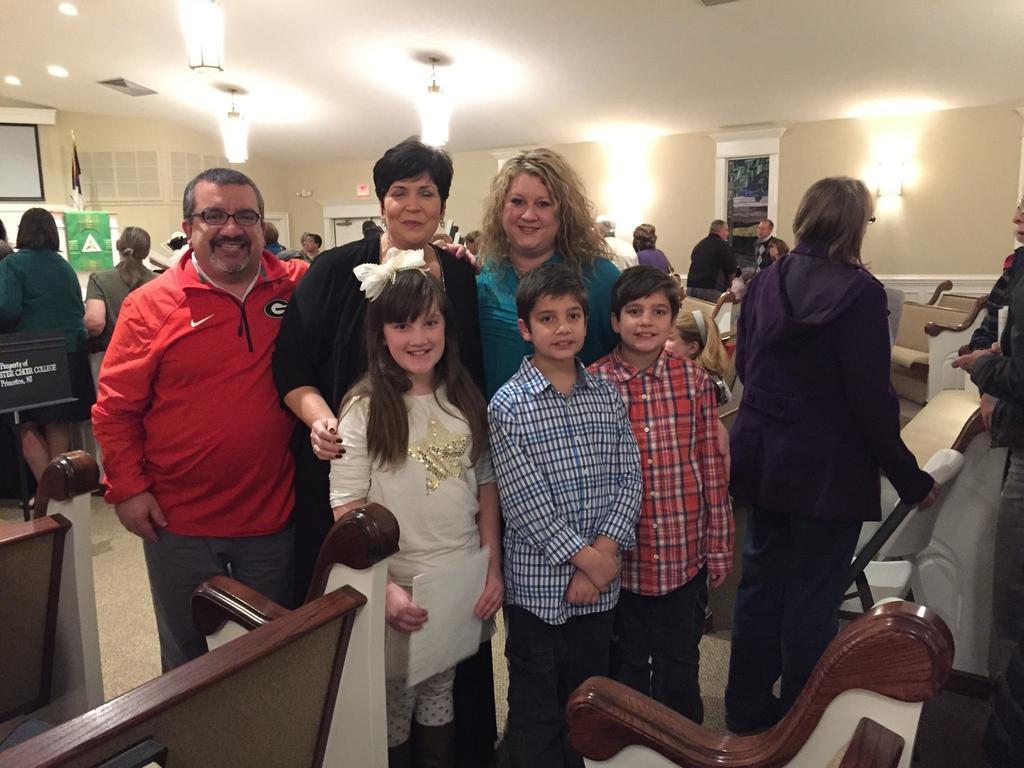Can you describe this image briefly? In this picture there are people those who are standing in the center of the image and there are benches at the bottom side of the image and there are other people and posters in the background area of the image, there are lamps at the top side of the image, there is a flag in the background area of the image.- 